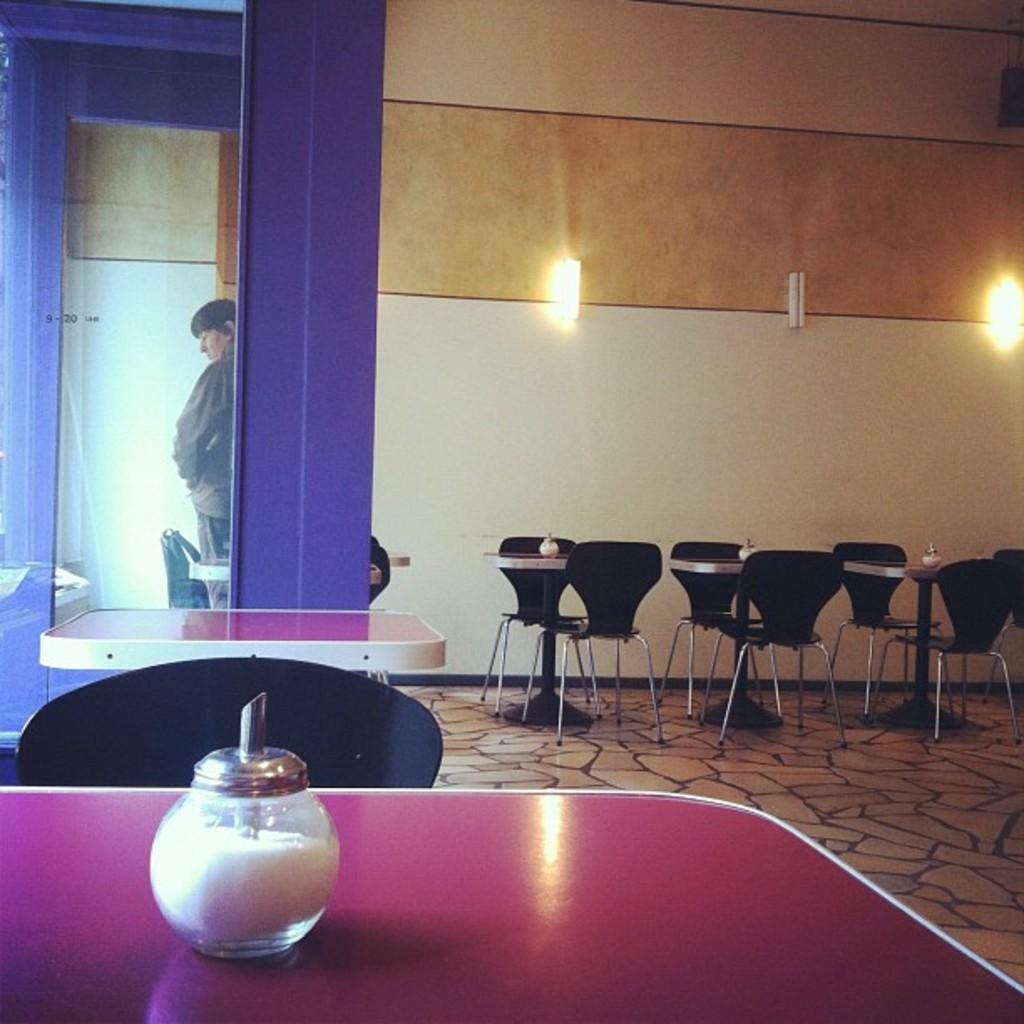Can you describe this image briefly? In this image we can see tables, chairs, glass, and a person. On the tables there are bottles. Here we can see floor. In the background there are lights and a wall. 